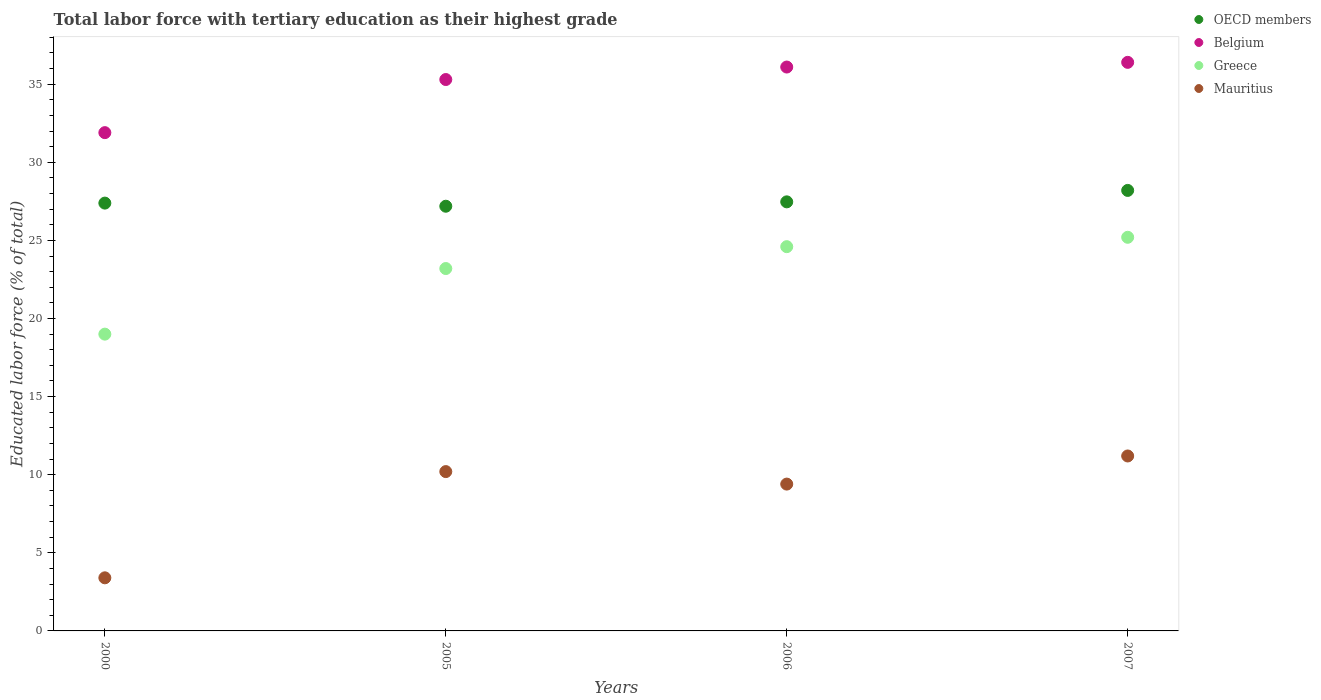Is the number of dotlines equal to the number of legend labels?
Keep it short and to the point. Yes. What is the percentage of male labor force with tertiary education in Mauritius in 2007?
Offer a very short reply. 11.2. Across all years, what is the maximum percentage of male labor force with tertiary education in Mauritius?
Provide a succinct answer. 11.2. Across all years, what is the minimum percentage of male labor force with tertiary education in Mauritius?
Provide a short and direct response. 3.4. What is the total percentage of male labor force with tertiary education in Belgium in the graph?
Provide a succinct answer. 139.7. What is the difference between the percentage of male labor force with tertiary education in OECD members in 2005 and that in 2006?
Offer a very short reply. -0.28. What is the difference between the percentage of male labor force with tertiary education in OECD members in 2000 and the percentage of male labor force with tertiary education in Greece in 2007?
Offer a terse response. 2.19. What is the average percentage of male labor force with tertiary education in Greece per year?
Your response must be concise. 23. In the year 2007, what is the difference between the percentage of male labor force with tertiary education in OECD members and percentage of male labor force with tertiary education in Belgium?
Keep it short and to the point. -8.2. In how many years, is the percentage of male labor force with tertiary education in Mauritius greater than 17 %?
Keep it short and to the point. 0. What is the ratio of the percentage of male labor force with tertiary education in Greece in 2006 to that in 2007?
Your answer should be very brief. 0.98. What is the difference between the highest and the lowest percentage of male labor force with tertiary education in Belgium?
Ensure brevity in your answer.  4.5. In how many years, is the percentage of male labor force with tertiary education in Mauritius greater than the average percentage of male labor force with tertiary education in Mauritius taken over all years?
Your answer should be very brief. 3. Is the sum of the percentage of male labor force with tertiary education in Belgium in 2005 and 2006 greater than the maximum percentage of male labor force with tertiary education in Greece across all years?
Provide a succinct answer. Yes. Is it the case that in every year, the sum of the percentage of male labor force with tertiary education in Greece and percentage of male labor force with tertiary education in Mauritius  is greater than the sum of percentage of male labor force with tertiary education in OECD members and percentage of male labor force with tertiary education in Belgium?
Make the answer very short. No. Is it the case that in every year, the sum of the percentage of male labor force with tertiary education in OECD members and percentage of male labor force with tertiary education in Greece  is greater than the percentage of male labor force with tertiary education in Mauritius?
Make the answer very short. Yes. Does the percentage of male labor force with tertiary education in Belgium monotonically increase over the years?
Your response must be concise. Yes. Is the percentage of male labor force with tertiary education in Mauritius strictly less than the percentage of male labor force with tertiary education in Belgium over the years?
Your answer should be very brief. Yes. What is the difference between two consecutive major ticks on the Y-axis?
Provide a succinct answer. 5. Are the values on the major ticks of Y-axis written in scientific E-notation?
Give a very brief answer. No. Does the graph contain any zero values?
Your answer should be very brief. No. Does the graph contain grids?
Give a very brief answer. No. How many legend labels are there?
Offer a very short reply. 4. What is the title of the graph?
Your answer should be very brief. Total labor force with tertiary education as their highest grade. What is the label or title of the Y-axis?
Give a very brief answer. Educated labor force (% of total). What is the Educated labor force (% of total) in OECD members in 2000?
Keep it short and to the point. 27.39. What is the Educated labor force (% of total) of Belgium in 2000?
Provide a succinct answer. 31.9. What is the Educated labor force (% of total) in Greece in 2000?
Offer a terse response. 19. What is the Educated labor force (% of total) in Mauritius in 2000?
Provide a short and direct response. 3.4. What is the Educated labor force (% of total) of OECD members in 2005?
Your answer should be very brief. 27.19. What is the Educated labor force (% of total) in Belgium in 2005?
Your answer should be very brief. 35.3. What is the Educated labor force (% of total) of Greece in 2005?
Your response must be concise. 23.2. What is the Educated labor force (% of total) of Mauritius in 2005?
Ensure brevity in your answer.  10.2. What is the Educated labor force (% of total) in OECD members in 2006?
Your answer should be very brief. 27.47. What is the Educated labor force (% of total) of Belgium in 2006?
Keep it short and to the point. 36.1. What is the Educated labor force (% of total) in Greece in 2006?
Provide a succinct answer. 24.6. What is the Educated labor force (% of total) of Mauritius in 2006?
Provide a short and direct response. 9.4. What is the Educated labor force (% of total) of OECD members in 2007?
Your answer should be compact. 28.2. What is the Educated labor force (% of total) in Belgium in 2007?
Make the answer very short. 36.4. What is the Educated labor force (% of total) of Greece in 2007?
Offer a very short reply. 25.2. What is the Educated labor force (% of total) in Mauritius in 2007?
Your response must be concise. 11.2. Across all years, what is the maximum Educated labor force (% of total) in OECD members?
Keep it short and to the point. 28.2. Across all years, what is the maximum Educated labor force (% of total) of Belgium?
Your response must be concise. 36.4. Across all years, what is the maximum Educated labor force (% of total) in Greece?
Keep it short and to the point. 25.2. Across all years, what is the maximum Educated labor force (% of total) of Mauritius?
Provide a succinct answer. 11.2. Across all years, what is the minimum Educated labor force (% of total) of OECD members?
Your answer should be very brief. 27.19. Across all years, what is the minimum Educated labor force (% of total) in Belgium?
Your response must be concise. 31.9. Across all years, what is the minimum Educated labor force (% of total) of Mauritius?
Your response must be concise. 3.4. What is the total Educated labor force (% of total) in OECD members in the graph?
Your answer should be very brief. 110.25. What is the total Educated labor force (% of total) of Belgium in the graph?
Your answer should be compact. 139.7. What is the total Educated labor force (% of total) in Greece in the graph?
Make the answer very short. 92. What is the total Educated labor force (% of total) of Mauritius in the graph?
Offer a terse response. 34.2. What is the difference between the Educated labor force (% of total) of OECD members in 2000 and that in 2005?
Make the answer very short. 0.2. What is the difference between the Educated labor force (% of total) of Belgium in 2000 and that in 2005?
Your answer should be very brief. -3.4. What is the difference between the Educated labor force (% of total) in OECD members in 2000 and that in 2006?
Offer a very short reply. -0.08. What is the difference between the Educated labor force (% of total) of Belgium in 2000 and that in 2006?
Offer a very short reply. -4.2. What is the difference between the Educated labor force (% of total) in Greece in 2000 and that in 2006?
Make the answer very short. -5.6. What is the difference between the Educated labor force (% of total) of Mauritius in 2000 and that in 2006?
Your answer should be compact. -6. What is the difference between the Educated labor force (% of total) in OECD members in 2000 and that in 2007?
Your answer should be compact. -0.81. What is the difference between the Educated labor force (% of total) in Belgium in 2000 and that in 2007?
Your answer should be compact. -4.5. What is the difference between the Educated labor force (% of total) in Greece in 2000 and that in 2007?
Keep it short and to the point. -6.2. What is the difference between the Educated labor force (% of total) of OECD members in 2005 and that in 2006?
Ensure brevity in your answer.  -0.28. What is the difference between the Educated labor force (% of total) of Belgium in 2005 and that in 2006?
Your response must be concise. -0.8. What is the difference between the Educated labor force (% of total) in Mauritius in 2005 and that in 2006?
Give a very brief answer. 0.8. What is the difference between the Educated labor force (% of total) in OECD members in 2005 and that in 2007?
Your response must be concise. -1.01. What is the difference between the Educated labor force (% of total) in Belgium in 2005 and that in 2007?
Your answer should be very brief. -1.1. What is the difference between the Educated labor force (% of total) in OECD members in 2006 and that in 2007?
Keep it short and to the point. -0.73. What is the difference between the Educated labor force (% of total) of Greece in 2006 and that in 2007?
Your answer should be compact. -0.6. What is the difference between the Educated labor force (% of total) of Mauritius in 2006 and that in 2007?
Give a very brief answer. -1.8. What is the difference between the Educated labor force (% of total) of OECD members in 2000 and the Educated labor force (% of total) of Belgium in 2005?
Provide a short and direct response. -7.91. What is the difference between the Educated labor force (% of total) of OECD members in 2000 and the Educated labor force (% of total) of Greece in 2005?
Provide a succinct answer. 4.19. What is the difference between the Educated labor force (% of total) in OECD members in 2000 and the Educated labor force (% of total) in Mauritius in 2005?
Ensure brevity in your answer.  17.19. What is the difference between the Educated labor force (% of total) of Belgium in 2000 and the Educated labor force (% of total) of Mauritius in 2005?
Offer a terse response. 21.7. What is the difference between the Educated labor force (% of total) in OECD members in 2000 and the Educated labor force (% of total) in Belgium in 2006?
Give a very brief answer. -8.71. What is the difference between the Educated labor force (% of total) of OECD members in 2000 and the Educated labor force (% of total) of Greece in 2006?
Your response must be concise. 2.79. What is the difference between the Educated labor force (% of total) of OECD members in 2000 and the Educated labor force (% of total) of Mauritius in 2006?
Your response must be concise. 17.99. What is the difference between the Educated labor force (% of total) of Belgium in 2000 and the Educated labor force (% of total) of Mauritius in 2006?
Provide a short and direct response. 22.5. What is the difference between the Educated labor force (% of total) in OECD members in 2000 and the Educated labor force (% of total) in Belgium in 2007?
Offer a very short reply. -9.01. What is the difference between the Educated labor force (% of total) of OECD members in 2000 and the Educated labor force (% of total) of Greece in 2007?
Make the answer very short. 2.19. What is the difference between the Educated labor force (% of total) in OECD members in 2000 and the Educated labor force (% of total) in Mauritius in 2007?
Your answer should be very brief. 16.19. What is the difference between the Educated labor force (% of total) of Belgium in 2000 and the Educated labor force (% of total) of Greece in 2007?
Provide a short and direct response. 6.7. What is the difference between the Educated labor force (% of total) in Belgium in 2000 and the Educated labor force (% of total) in Mauritius in 2007?
Give a very brief answer. 20.7. What is the difference between the Educated labor force (% of total) of OECD members in 2005 and the Educated labor force (% of total) of Belgium in 2006?
Offer a terse response. -8.91. What is the difference between the Educated labor force (% of total) in OECD members in 2005 and the Educated labor force (% of total) in Greece in 2006?
Provide a succinct answer. 2.59. What is the difference between the Educated labor force (% of total) of OECD members in 2005 and the Educated labor force (% of total) of Mauritius in 2006?
Provide a succinct answer. 17.79. What is the difference between the Educated labor force (% of total) of Belgium in 2005 and the Educated labor force (% of total) of Greece in 2006?
Keep it short and to the point. 10.7. What is the difference between the Educated labor force (% of total) of Belgium in 2005 and the Educated labor force (% of total) of Mauritius in 2006?
Provide a succinct answer. 25.9. What is the difference between the Educated labor force (% of total) of Greece in 2005 and the Educated labor force (% of total) of Mauritius in 2006?
Provide a succinct answer. 13.8. What is the difference between the Educated labor force (% of total) of OECD members in 2005 and the Educated labor force (% of total) of Belgium in 2007?
Offer a terse response. -9.21. What is the difference between the Educated labor force (% of total) in OECD members in 2005 and the Educated labor force (% of total) in Greece in 2007?
Offer a terse response. 1.99. What is the difference between the Educated labor force (% of total) in OECD members in 2005 and the Educated labor force (% of total) in Mauritius in 2007?
Your answer should be compact. 15.99. What is the difference between the Educated labor force (% of total) in Belgium in 2005 and the Educated labor force (% of total) in Mauritius in 2007?
Provide a succinct answer. 24.1. What is the difference between the Educated labor force (% of total) of Greece in 2005 and the Educated labor force (% of total) of Mauritius in 2007?
Keep it short and to the point. 12. What is the difference between the Educated labor force (% of total) in OECD members in 2006 and the Educated labor force (% of total) in Belgium in 2007?
Your answer should be compact. -8.93. What is the difference between the Educated labor force (% of total) in OECD members in 2006 and the Educated labor force (% of total) in Greece in 2007?
Ensure brevity in your answer.  2.27. What is the difference between the Educated labor force (% of total) in OECD members in 2006 and the Educated labor force (% of total) in Mauritius in 2007?
Your answer should be very brief. 16.27. What is the difference between the Educated labor force (% of total) in Belgium in 2006 and the Educated labor force (% of total) in Greece in 2007?
Your answer should be compact. 10.9. What is the difference between the Educated labor force (% of total) in Belgium in 2006 and the Educated labor force (% of total) in Mauritius in 2007?
Your answer should be very brief. 24.9. What is the average Educated labor force (% of total) of OECD members per year?
Ensure brevity in your answer.  27.56. What is the average Educated labor force (% of total) in Belgium per year?
Keep it short and to the point. 34.92. What is the average Educated labor force (% of total) of Greece per year?
Ensure brevity in your answer.  23. What is the average Educated labor force (% of total) of Mauritius per year?
Your response must be concise. 8.55. In the year 2000, what is the difference between the Educated labor force (% of total) of OECD members and Educated labor force (% of total) of Belgium?
Offer a very short reply. -4.51. In the year 2000, what is the difference between the Educated labor force (% of total) in OECD members and Educated labor force (% of total) in Greece?
Provide a succinct answer. 8.39. In the year 2000, what is the difference between the Educated labor force (% of total) of OECD members and Educated labor force (% of total) of Mauritius?
Your answer should be compact. 23.99. In the year 2000, what is the difference between the Educated labor force (% of total) of Belgium and Educated labor force (% of total) of Greece?
Provide a succinct answer. 12.9. In the year 2000, what is the difference between the Educated labor force (% of total) in Belgium and Educated labor force (% of total) in Mauritius?
Your answer should be very brief. 28.5. In the year 2000, what is the difference between the Educated labor force (% of total) in Greece and Educated labor force (% of total) in Mauritius?
Provide a short and direct response. 15.6. In the year 2005, what is the difference between the Educated labor force (% of total) in OECD members and Educated labor force (% of total) in Belgium?
Give a very brief answer. -8.11. In the year 2005, what is the difference between the Educated labor force (% of total) of OECD members and Educated labor force (% of total) of Greece?
Give a very brief answer. 3.99. In the year 2005, what is the difference between the Educated labor force (% of total) of OECD members and Educated labor force (% of total) of Mauritius?
Provide a succinct answer. 16.99. In the year 2005, what is the difference between the Educated labor force (% of total) of Belgium and Educated labor force (% of total) of Mauritius?
Give a very brief answer. 25.1. In the year 2006, what is the difference between the Educated labor force (% of total) in OECD members and Educated labor force (% of total) in Belgium?
Ensure brevity in your answer.  -8.63. In the year 2006, what is the difference between the Educated labor force (% of total) in OECD members and Educated labor force (% of total) in Greece?
Offer a terse response. 2.87. In the year 2006, what is the difference between the Educated labor force (% of total) in OECD members and Educated labor force (% of total) in Mauritius?
Your answer should be very brief. 18.07. In the year 2006, what is the difference between the Educated labor force (% of total) in Belgium and Educated labor force (% of total) in Mauritius?
Offer a very short reply. 26.7. In the year 2006, what is the difference between the Educated labor force (% of total) of Greece and Educated labor force (% of total) of Mauritius?
Provide a succinct answer. 15.2. In the year 2007, what is the difference between the Educated labor force (% of total) of OECD members and Educated labor force (% of total) of Belgium?
Your answer should be compact. -8.2. In the year 2007, what is the difference between the Educated labor force (% of total) of OECD members and Educated labor force (% of total) of Greece?
Make the answer very short. 3. In the year 2007, what is the difference between the Educated labor force (% of total) of OECD members and Educated labor force (% of total) of Mauritius?
Give a very brief answer. 17. In the year 2007, what is the difference between the Educated labor force (% of total) of Belgium and Educated labor force (% of total) of Greece?
Your answer should be compact. 11.2. In the year 2007, what is the difference between the Educated labor force (% of total) in Belgium and Educated labor force (% of total) in Mauritius?
Offer a very short reply. 25.2. In the year 2007, what is the difference between the Educated labor force (% of total) in Greece and Educated labor force (% of total) in Mauritius?
Your answer should be very brief. 14. What is the ratio of the Educated labor force (% of total) in OECD members in 2000 to that in 2005?
Provide a short and direct response. 1.01. What is the ratio of the Educated labor force (% of total) of Belgium in 2000 to that in 2005?
Provide a succinct answer. 0.9. What is the ratio of the Educated labor force (% of total) of Greece in 2000 to that in 2005?
Make the answer very short. 0.82. What is the ratio of the Educated labor force (% of total) of Mauritius in 2000 to that in 2005?
Make the answer very short. 0.33. What is the ratio of the Educated labor force (% of total) of OECD members in 2000 to that in 2006?
Give a very brief answer. 1. What is the ratio of the Educated labor force (% of total) of Belgium in 2000 to that in 2006?
Provide a short and direct response. 0.88. What is the ratio of the Educated labor force (% of total) in Greece in 2000 to that in 2006?
Provide a short and direct response. 0.77. What is the ratio of the Educated labor force (% of total) of Mauritius in 2000 to that in 2006?
Provide a succinct answer. 0.36. What is the ratio of the Educated labor force (% of total) of OECD members in 2000 to that in 2007?
Provide a short and direct response. 0.97. What is the ratio of the Educated labor force (% of total) in Belgium in 2000 to that in 2007?
Give a very brief answer. 0.88. What is the ratio of the Educated labor force (% of total) of Greece in 2000 to that in 2007?
Offer a very short reply. 0.75. What is the ratio of the Educated labor force (% of total) of Mauritius in 2000 to that in 2007?
Your answer should be compact. 0.3. What is the ratio of the Educated labor force (% of total) in OECD members in 2005 to that in 2006?
Your answer should be very brief. 0.99. What is the ratio of the Educated labor force (% of total) of Belgium in 2005 to that in 2006?
Your answer should be very brief. 0.98. What is the ratio of the Educated labor force (% of total) in Greece in 2005 to that in 2006?
Your answer should be very brief. 0.94. What is the ratio of the Educated labor force (% of total) in Mauritius in 2005 to that in 2006?
Offer a very short reply. 1.09. What is the ratio of the Educated labor force (% of total) in OECD members in 2005 to that in 2007?
Offer a terse response. 0.96. What is the ratio of the Educated labor force (% of total) of Belgium in 2005 to that in 2007?
Your response must be concise. 0.97. What is the ratio of the Educated labor force (% of total) of Greece in 2005 to that in 2007?
Offer a very short reply. 0.92. What is the ratio of the Educated labor force (% of total) in Mauritius in 2005 to that in 2007?
Provide a short and direct response. 0.91. What is the ratio of the Educated labor force (% of total) of OECD members in 2006 to that in 2007?
Provide a short and direct response. 0.97. What is the ratio of the Educated labor force (% of total) of Belgium in 2006 to that in 2007?
Your answer should be compact. 0.99. What is the ratio of the Educated labor force (% of total) in Greece in 2006 to that in 2007?
Keep it short and to the point. 0.98. What is the ratio of the Educated labor force (% of total) of Mauritius in 2006 to that in 2007?
Offer a terse response. 0.84. What is the difference between the highest and the second highest Educated labor force (% of total) of OECD members?
Your answer should be compact. 0.73. What is the difference between the highest and the second highest Educated labor force (% of total) of Belgium?
Ensure brevity in your answer.  0.3. What is the difference between the highest and the second highest Educated labor force (% of total) in Greece?
Provide a succinct answer. 0.6. What is the difference between the highest and the lowest Educated labor force (% of total) of OECD members?
Give a very brief answer. 1.01. What is the difference between the highest and the lowest Educated labor force (% of total) in Belgium?
Provide a short and direct response. 4.5. What is the difference between the highest and the lowest Educated labor force (% of total) of Mauritius?
Offer a terse response. 7.8. 